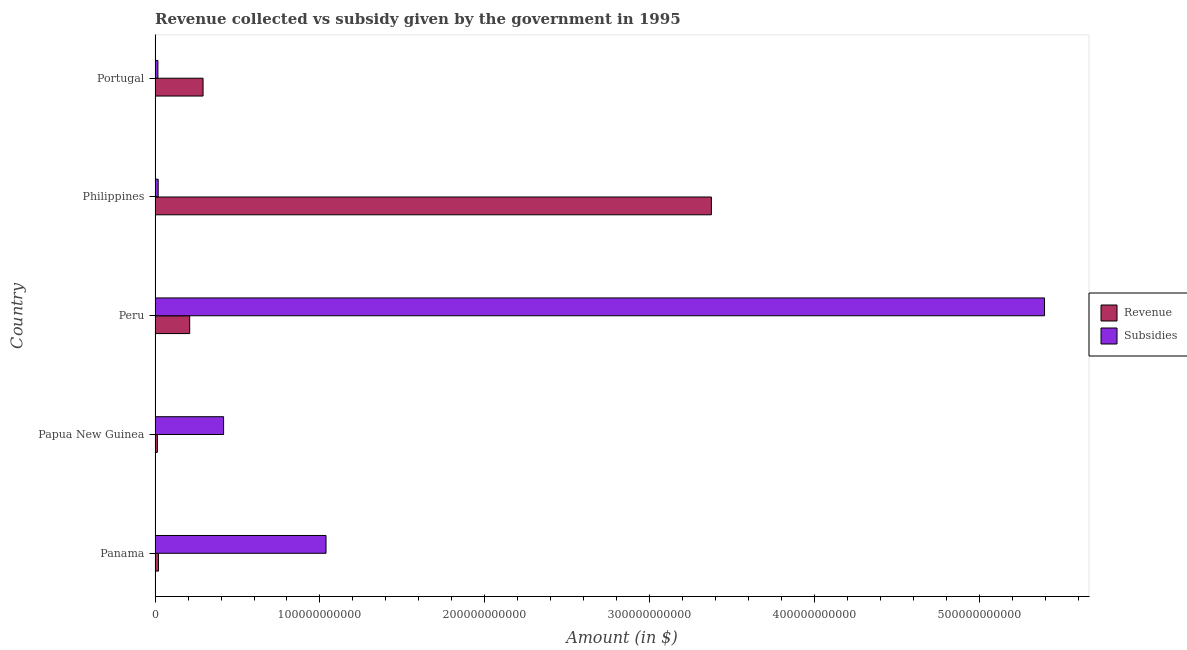Are the number of bars on each tick of the Y-axis equal?
Your answer should be very brief. Yes. How many bars are there on the 3rd tick from the top?
Provide a succinct answer. 2. How many bars are there on the 1st tick from the bottom?
Provide a succinct answer. 2. What is the label of the 5th group of bars from the top?
Ensure brevity in your answer.  Panama. What is the amount of revenue collected in Papua New Guinea?
Your response must be concise. 1.41e+09. Across all countries, what is the maximum amount of revenue collected?
Your answer should be very brief. 3.37e+11. Across all countries, what is the minimum amount of revenue collected?
Provide a short and direct response. 1.41e+09. In which country was the amount of subsidies given maximum?
Make the answer very short. Peru. In which country was the amount of revenue collected minimum?
Offer a terse response. Papua New Guinea. What is the total amount of revenue collected in the graph?
Provide a short and direct response. 3.91e+11. What is the difference between the amount of subsidies given in Panama and that in Philippines?
Make the answer very short. 1.02e+11. What is the difference between the amount of subsidies given in Philippines and the amount of revenue collected in Papua New Guinea?
Offer a very short reply. 4.93e+08. What is the average amount of subsidies given per country?
Provide a succinct answer. 1.38e+11. What is the difference between the amount of revenue collected and amount of subsidies given in Panama?
Provide a succinct answer. -1.02e+11. What is the ratio of the amount of subsidies given in Panama to that in Papua New Guinea?
Your response must be concise. 2.5. Is the amount of subsidies given in Philippines less than that in Portugal?
Keep it short and to the point. No. What is the difference between the highest and the second highest amount of revenue collected?
Offer a terse response. 3.08e+11. What is the difference between the highest and the lowest amount of revenue collected?
Your response must be concise. 3.36e+11. In how many countries, is the amount of revenue collected greater than the average amount of revenue collected taken over all countries?
Offer a terse response. 1. What does the 2nd bar from the top in Peru represents?
Your response must be concise. Revenue. What does the 1st bar from the bottom in Panama represents?
Provide a short and direct response. Revenue. How many bars are there?
Your response must be concise. 10. Are all the bars in the graph horizontal?
Your answer should be very brief. Yes. What is the difference between two consecutive major ticks on the X-axis?
Keep it short and to the point. 1.00e+11. Are the values on the major ticks of X-axis written in scientific E-notation?
Keep it short and to the point. No. How are the legend labels stacked?
Your response must be concise. Vertical. What is the title of the graph?
Your answer should be compact. Revenue collected vs subsidy given by the government in 1995. What is the label or title of the X-axis?
Your answer should be very brief. Amount (in $). What is the Amount (in $) in Revenue in Panama?
Provide a short and direct response. 2.06e+09. What is the Amount (in $) of Subsidies in Panama?
Your response must be concise. 1.04e+11. What is the Amount (in $) in Revenue in Papua New Guinea?
Your response must be concise. 1.41e+09. What is the Amount (in $) of Subsidies in Papua New Guinea?
Offer a terse response. 4.16e+1. What is the Amount (in $) in Revenue in Peru?
Offer a terse response. 2.10e+1. What is the Amount (in $) in Subsidies in Peru?
Make the answer very short. 5.39e+11. What is the Amount (in $) in Revenue in Philippines?
Provide a short and direct response. 3.37e+11. What is the Amount (in $) of Subsidies in Philippines?
Offer a terse response. 1.90e+09. What is the Amount (in $) of Revenue in Portugal?
Provide a short and direct response. 2.91e+1. What is the Amount (in $) in Subsidies in Portugal?
Provide a succinct answer. 1.72e+09. Across all countries, what is the maximum Amount (in $) of Revenue?
Provide a short and direct response. 3.37e+11. Across all countries, what is the maximum Amount (in $) in Subsidies?
Ensure brevity in your answer.  5.39e+11. Across all countries, what is the minimum Amount (in $) of Revenue?
Give a very brief answer. 1.41e+09. Across all countries, what is the minimum Amount (in $) of Subsidies?
Give a very brief answer. 1.72e+09. What is the total Amount (in $) in Revenue in the graph?
Your response must be concise. 3.91e+11. What is the total Amount (in $) in Subsidies in the graph?
Your answer should be compact. 6.88e+11. What is the difference between the Amount (in $) of Revenue in Panama and that in Papua New Guinea?
Offer a terse response. 6.58e+08. What is the difference between the Amount (in $) of Subsidies in Panama and that in Papua New Guinea?
Keep it short and to the point. 6.21e+1. What is the difference between the Amount (in $) in Revenue in Panama and that in Peru?
Your answer should be compact. -1.89e+1. What is the difference between the Amount (in $) in Subsidies in Panama and that in Peru?
Your response must be concise. -4.36e+11. What is the difference between the Amount (in $) of Revenue in Panama and that in Philippines?
Your answer should be very brief. -3.35e+11. What is the difference between the Amount (in $) in Subsidies in Panama and that in Philippines?
Your answer should be compact. 1.02e+11. What is the difference between the Amount (in $) of Revenue in Panama and that in Portugal?
Your answer should be very brief. -2.70e+1. What is the difference between the Amount (in $) of Subsidies in Panama and that in Portugal?
Offer a terse response. 1.02e+11. What is the difference between the Amount (in $) of Revenue in Papua New Guinea and that in Peru?
Ensure brevity in your answer.  -1.96e+1. What is the difference between the Amount (in $) in Subsidies in Papua New Guinea and that in Peru?
Ensure brevity in your answer.  -4.98e+11. What is the difference between the Amount (in $) of Revenue in Papua New Guinea and that in Philippines?
Provide a short and direct response. -3.36e+11. What is the difference between the Amount (in $) of Subsidies in Papua New Guinea and that in Philippines?
Ensure brevity in your answer.  3.97e+1. What is the difference between the Amount (in $) in Revenue in Papua New Guinea and that in Portugal?
Keep it short and to the point. -2.77e+1. What is the difference between the Amount (in $) in Subsidies in Papua New Guinea and that in Portugal?
Offer a very short reply. 3.98e+1. What is the difference between the Amount (in $) in Revenue in Peru and that in Philippines?
Provide a succinct answer. -3.16e+11. What is the difference between the Amount (in $) of Subsidies in Peru and that in Philippines?
Ensure brevity in your answer.  5.38e+11. What is the difference between the Amount (in $) in Revenue in Peru and that in Portugal?
Your response must be concise. -8.11e+09. What is the difference between the Amount (in $) in Subsidies in Peru and that in Portugal?
Provide a short and direct response. 5.38e+11. What is the difference between the Amount (in $) in Revenue in Philippines and that in Portugal?
Your answer should be compact. 3.08e+11. What is the difference between the Amount (in $) of Subsidies in Philippines and that in Portugal?
Offer a terse response. 1.77e+08. What is the difference between the Amount (in $) of Revenue in Panama and the Amount (in $) of Subsidies in Papua New Guinea?
Offer a terse response. -3.95e+1. What is the difference between the Amount (in $) of Revenue in Panama and the Amount (in $) of Subsidies in Peru?
Your answer should be very brief. -5.37e+11. What is the difference between the Amount (in $) of Revenue in Panama and the Amount (in $) of Subsidies in Philippines?
Make the answer very short. 1.65e+08. What is the difference between the Amount (in $) in Revenue in Panama and the Amount (in $) in Subsidies in Portugal?
Offer a very short reply. 3.42e+08. What is the difference between the Amount (in $) of Revenue in Papua New Guinea and the Amount (in $) of Subsidies in Peru?
Offer a terse response. -5.38e+11. What is the difference between the Amount (in $) in Revenue in Papua New Guinea and the Amount (in $) in Subsidies in Philippines?
Keep it short and to the point. -4.93e+08. What is the difference between the Amount (in $) of Revenue in Papua New Guinea and the Amount (in $) of Subsidies in Portugal?
Offer a very short reply. -3.16e+08. What is the difference between the Amount (in $) of Revenue in Peru and the Amount (in $) of Subsidies in Philippines?
Provide a succinct answer. 1.91e+1. What is the difference between the Amount (in $) in Revenue in Peru and the Amount (in $) in Subsidies in Portugal?
Provide a short and direct response. 1.93e+1. What is the difference between the Amount (in $) of Revenue in Philippines and the Amount (in $) of Subsidies in Portugal?
Your answer should be compact. 3.36e+11. What is the average Amount (in $) of Revenue per country?
Offer a terse response. 7.82e+1. What is the average Amount (in $) in Subsidies per country?
Offer a terse response. 1.38e+11. What is the difference between the Amount (in $) of Revenue and Amount (in $) of Subsidies in Panama?
Keep it short and to the point. -1.02e+11. What is the difference between the Amount (in $) in Revenue and Amount (in $) in Subsidies in Papua New Guinea?
Ensure brevity in your answer.  -4.02e+1. What is the difference between the Amount (in $) in Revenue and Amount (in $) in Subsidies in Peru?
Give a very brief answer. -5.18e+11. What is the difference between the Amount (in $) of Revenue and Amount (in $) of Subsidies in Philippines?
Keep it short and to the point. 3.36e+11. What is the difference between the Amount (in $) of Revenue and Amount (in $) of Subsidies in Portugal?
Make the answer very short. 2.74e+1. What is the ratio of the Amount (in $) in Revenue in Panama to that in Papua New Guinea?
Your answer should be compact. 1.47. What is the ratio of the Amount (in $) of Subsidies in Panama to that in Papua New Guinea?
Make the answer very short. 2.49. What is the ratio of the Amount (in $) of Revenue in Panama to that in Peru?
Keep it short and to the point. 0.1. What is the ratio of the Amount (in $) of Subsidies in Panama to that in Peru?
Ensure brevity in your answer.  0.19. What is the ratio of the Amount (in $) of Revenue in Panama to that in Philippines?
Provide a short and direct response. 0.01. What is the ratio of the Amount (in $) in Subsidies in Panama to that in Philippines?
Offer a very short reply. 54.63. What is the ratio of the Amount (in $) in Revenue in Panama to that in Portugal?
Offer a very short reply. 0.07. What is the ratio of the Amount (in $) of Subsidies in Panama to that in Portugal?
Ensure brevity in your answer.  60.23. What is the ratio of the Amount (in $) of Revenue in Papua New Guinea to that in Peru?
Offer a very short reply. 0.07. What is the ratio of the Amount (in $) in Subsidies in Papua New Guinea to that in Peru?
Ensure brevity in your answer.  0.08. What is the ratio of the Amount (in $) in Revenue in Papua New Guinea to that in Philippines?
Offer a terse response. 0. What is the ratio of the Amount (in $) of Subsidies in Papua New Guinea to that in Philippines?
Offer a terse response. 21.9. What is the ratio of the Amount (in $) in Revenue in Papua New Guinea to that in Portugal?
Your response must be concise. 0.05. What is the ratio of the Amount (in $) in Subsidies in Papua New Guinea to that in Portugal?
Make the answer very short. 24.14. What is the ratio of the Amount (in $) of Revenue in Peru to that in Philippines?
Offer a very short reply. 0.06. What is the ratio of the Amount (in $) of Subsidies in Peru to that in Philippines?
Your answer should be very brief. 284.2. What is the ratio of the Amount (in $) in Revenue in Peru to that in Portugal?
Provide a short and direct response. 0.72. What is the ratio of the Amount (in $) in Subsidies in Peru to that in Portugal?
Ensure brevity in your answer.  313.36. What is the ratio of the Amount (in $) in Revenue in Philippines to that in Portugal?
Provide a short and direct response. 11.59. What is the ratio of the Amount (in $) in Subsidies in Philippines to that in Portugal?
Provide a short and direct response. 1.1. What is the difference between the highest and the second highest Amount (in $) in Revenue?
Provide a short and direct response. 3.08e+11. What is the difference between the highest and the second highest Amount (in $) in Subsidies?
Your answer should be compact. 4.36e+11. What is the difference between the highest and the lowest Amount (in $) in Revenue?
Your answer should be compact. 3.36e+11. What is the difference between the highest and the lowest Amount (in $) in Subsidies?
Offer a terse response. 5.38e+11. 